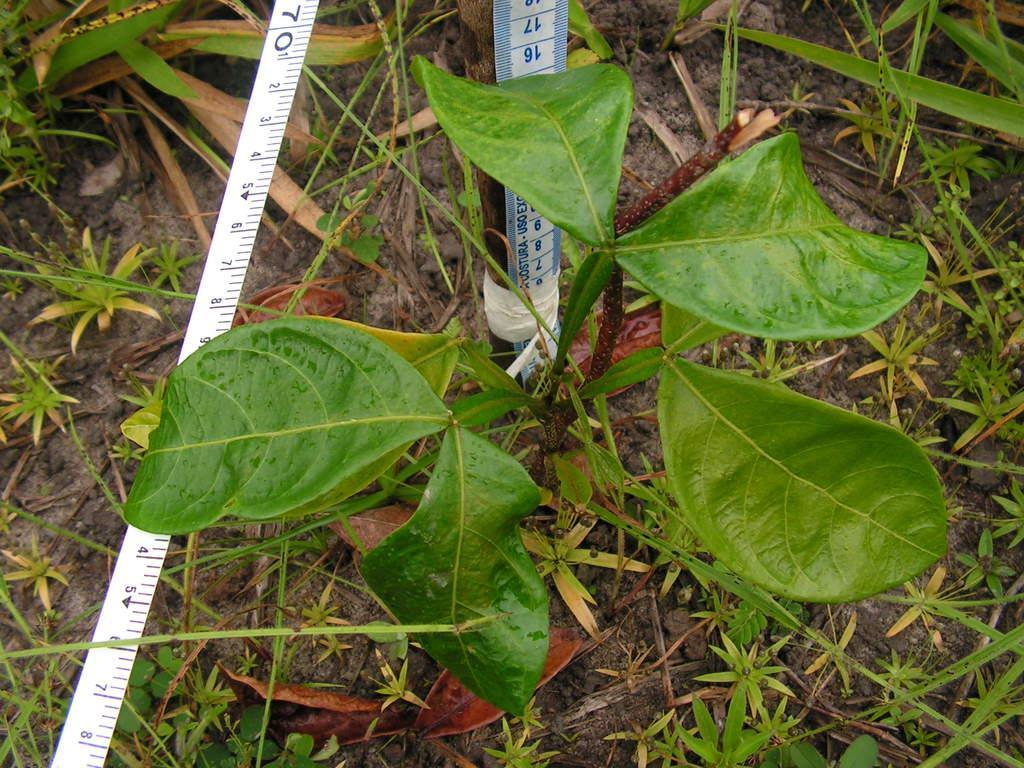Please provide a concise description of this image. On the left side, there is a white color tap. Beside this tap, there is a plant. Beside this plant, there is a tap attached to the wooden stick. In the background, there is grass on the ground. 